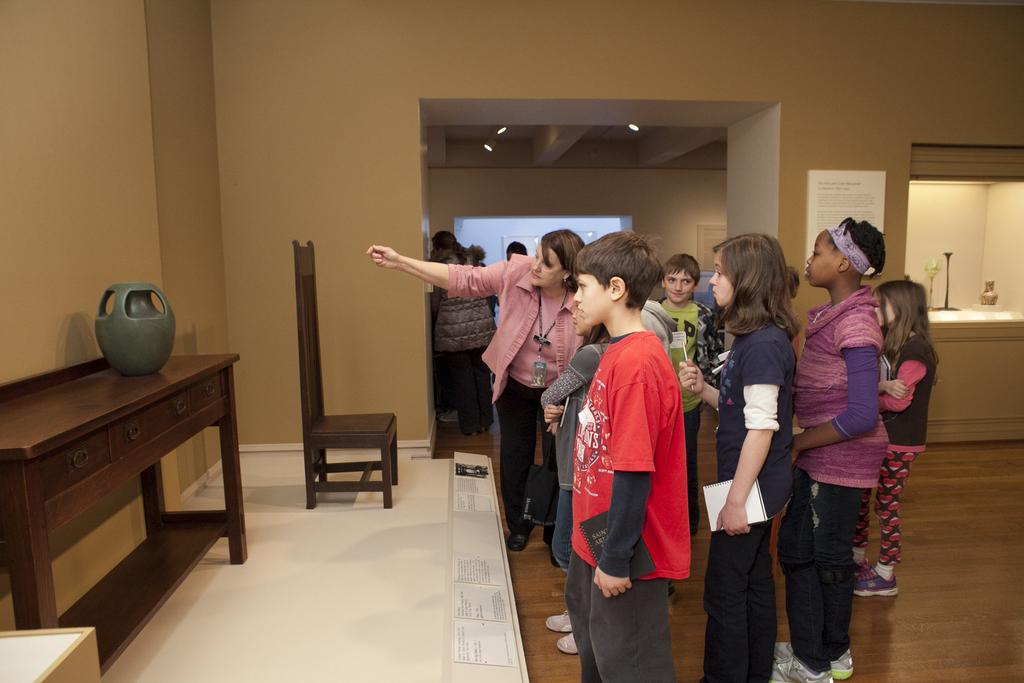How many people are in the image? There is a group of people in the image. Where are the people standing in relation to the wall? The people are standing in front of a wall. What is on the table in the image? There is an object on a table in the image. Can you describe any furniture in the image? There is a chair in the image. What can be seen in terms of lighting in the image? There are lights visible in the image. What type of bone is being used as a weapon by the army in the image? There is no army or bone present in the image. What part of the body is the arm in the image? There is no arm visible in the image. 